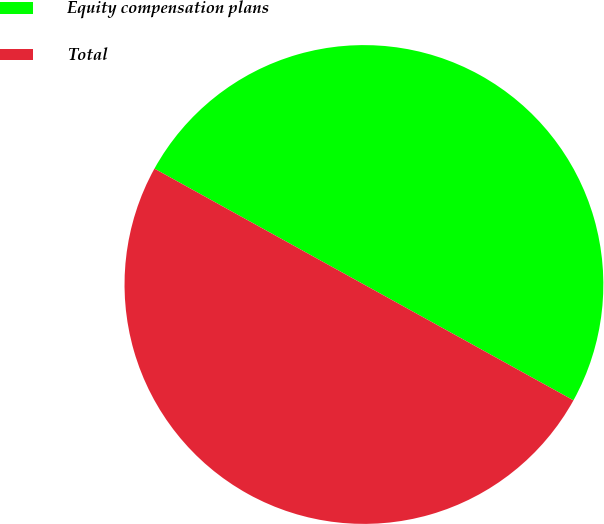Convert chart. <chart><loc_0><loc_0><loc_500><loc_500><pie_chart><fcel>Equity compensation plans<fcel>Total<nl><fcel>50.0%<fcel>50.0%<nl></chart> 